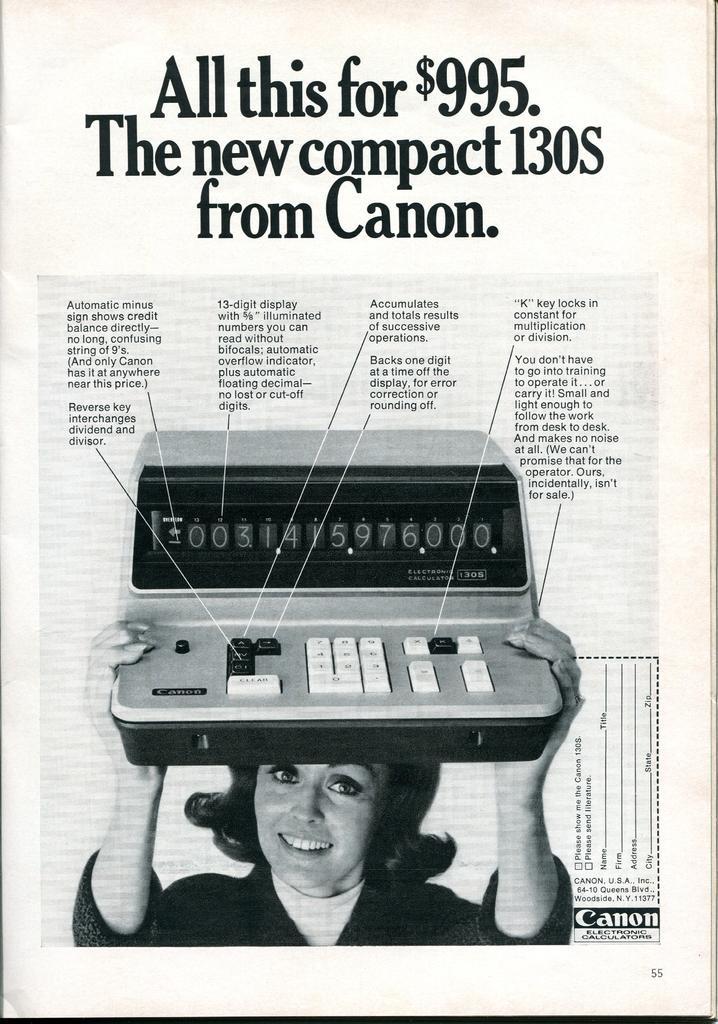Please provide a concise description of this image. It looks like a paper, and on the paper there is an image of a woman holding an object and on the paper it is written something. 